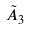<formula> <loc_0><loc_0><loc_500><loc_500>\tilde { A } _ { 3 }</formula> 